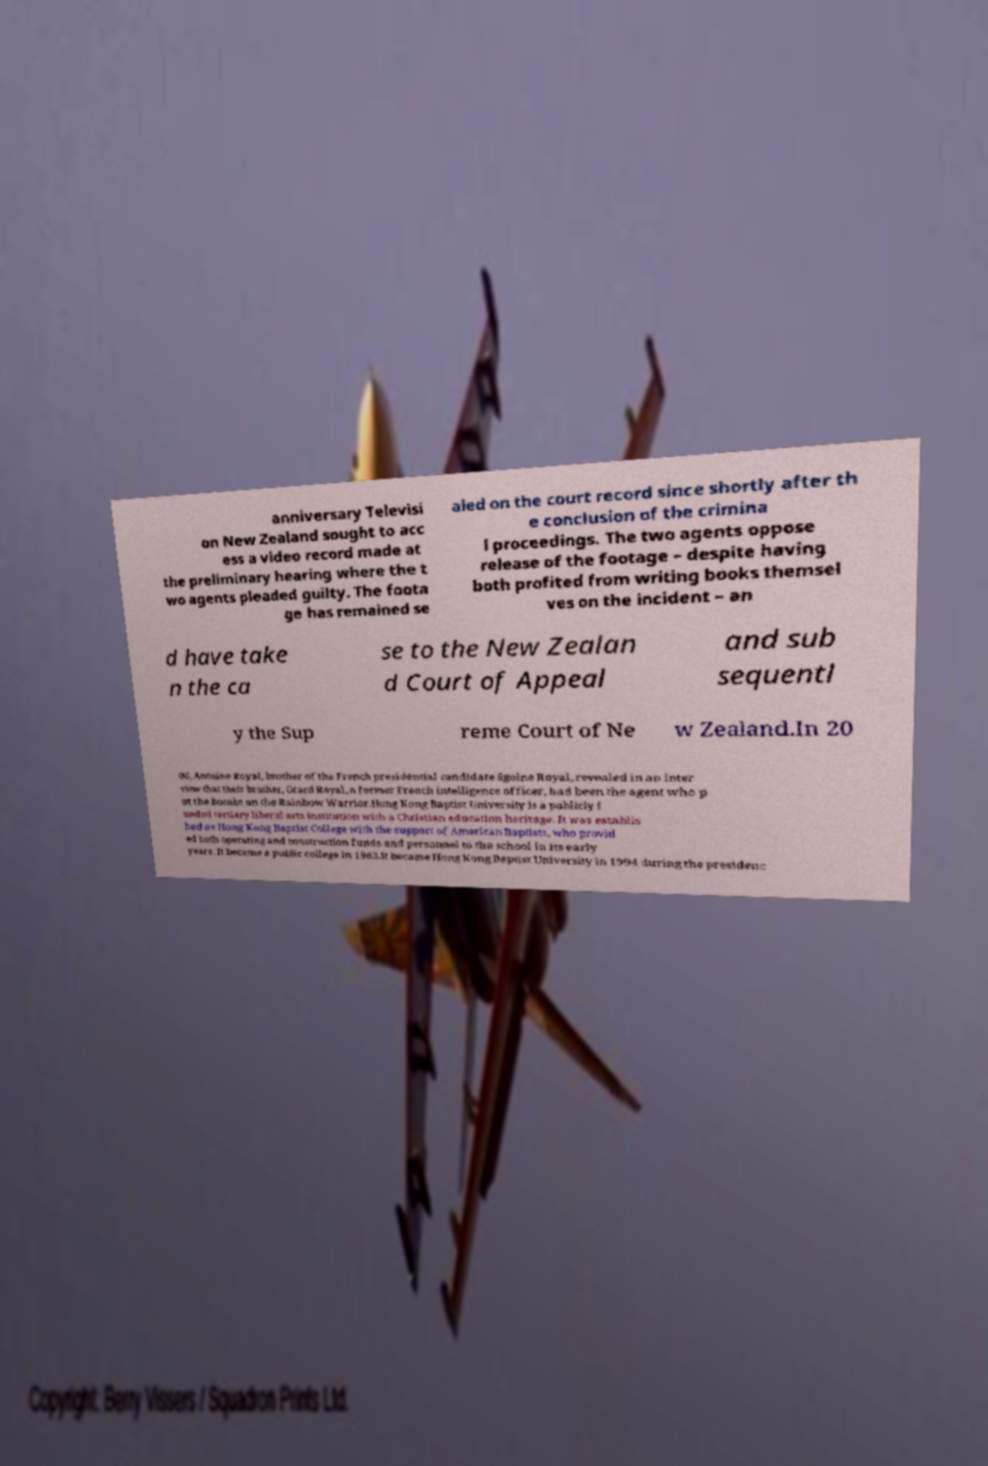Could you assist in decoding the text presented in this image and type it out clearly? anniversary Televisi on New Zealand sought to acc ess a video record made at the preliminary hearing where the t wo agents pleaded guilty. The foota ge has remained se aled on the court record since shortly after th e conclusion of the crimina l proceedings. The two agents oppose release of the footage – despite having both profited from writing books themsel ves on the incident – an d have take n the ca se to the New Zealan d Court of Appeal and sub sequentl y the Sup reme Court of Ne w Zealand.In 20 06, Antoine Royal, brother of the French presidential candidate Sgolne Royal, revealed in an inter view that their brother, Grard Royal, a former French intelligence officer, had been the agent who p ut the bombs on the Rainbow Warrior.Hong Kong Baptist University is a publicly f unded tertiary liberal arts institution with a Christian education heritage. It was establis hed as Hong Kong Baptist College with the support of American Baptists, who provid ed both operating and construction funds and personnel to the school in its early years. It became a public college in 1983.It became Hong Kong Baptist University in 1994 during the presidenc 